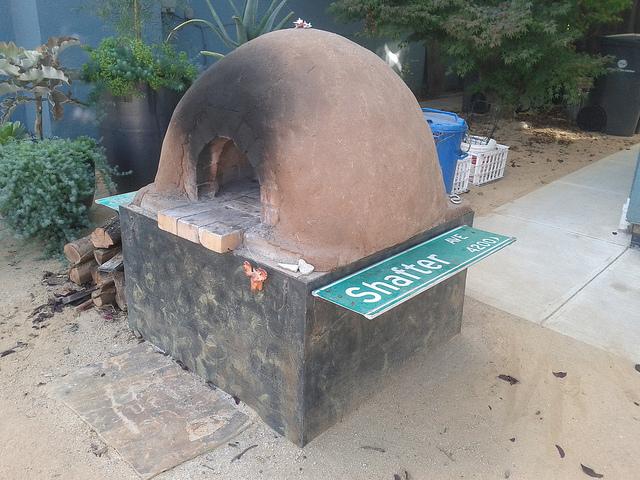Is there any firewood?
Give a very brief answer. Yes. What name is on the street sign?
Write a very short answer. Shafter. What is the object here?
Write a very short answer. Oven. 